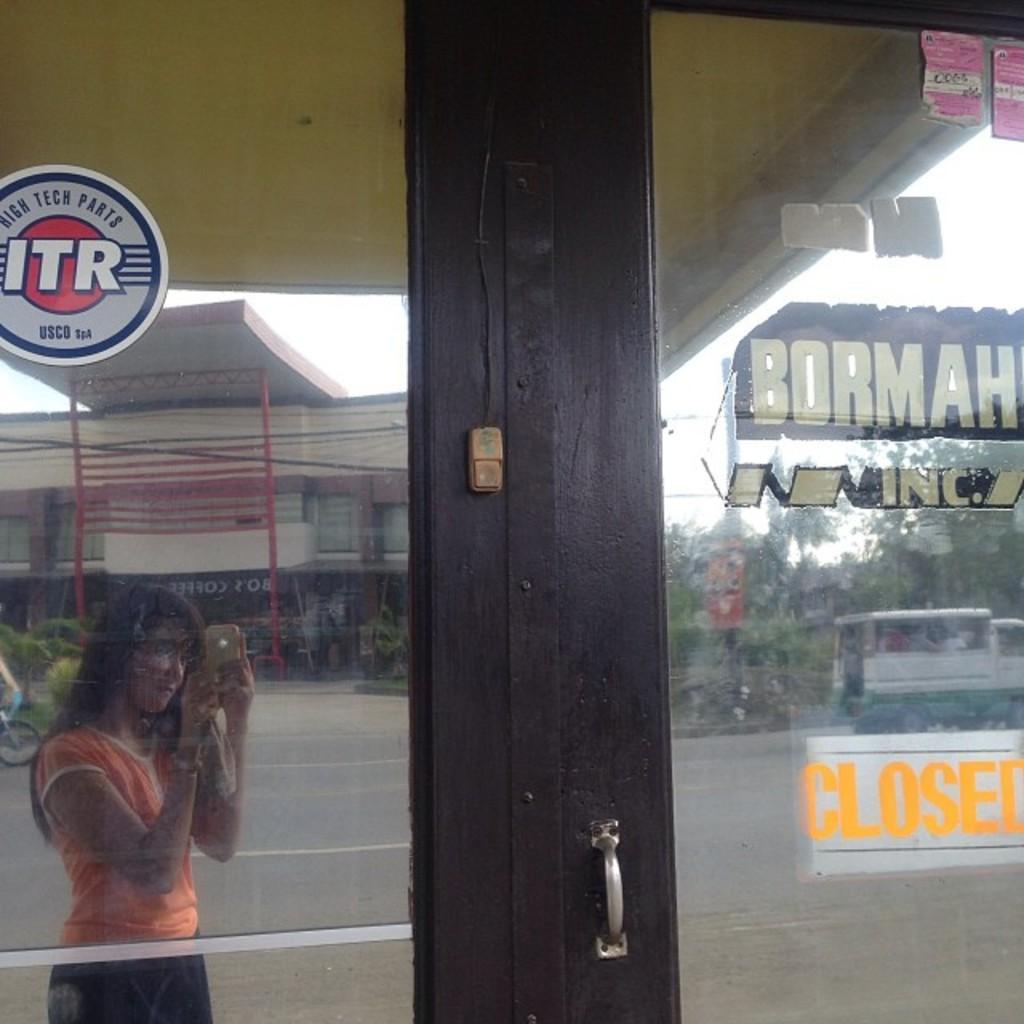Describe this image in one or two sentences. In this image we can see a glass door. In which there is a reflection of a girl. There is a reflection of buildings,trees,vehicle on the road and there is some text to the right side of the image. 